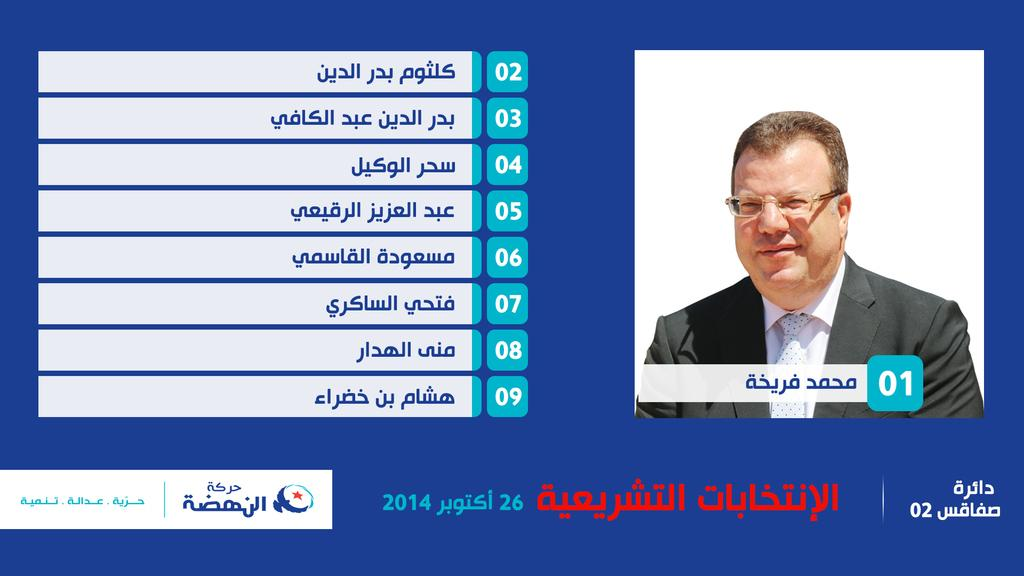What is present on the right side of the image? There is a person's image in the right side of the image. What is the person wearing in the image? The person is wearing a suit, a tie, and spectacles. What can be seen on the left side of the image? There is some text on the left side of the image. What is the color of the background in the image? The background is in blue color. What type of steel can be seen in the image? There is no steel present in the image. 